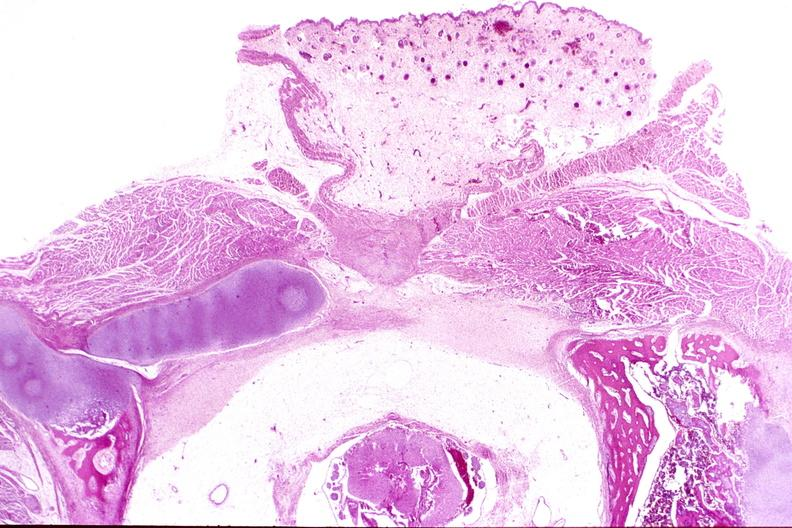what is present?
Answer the question using a single word or phrase. Nervous 